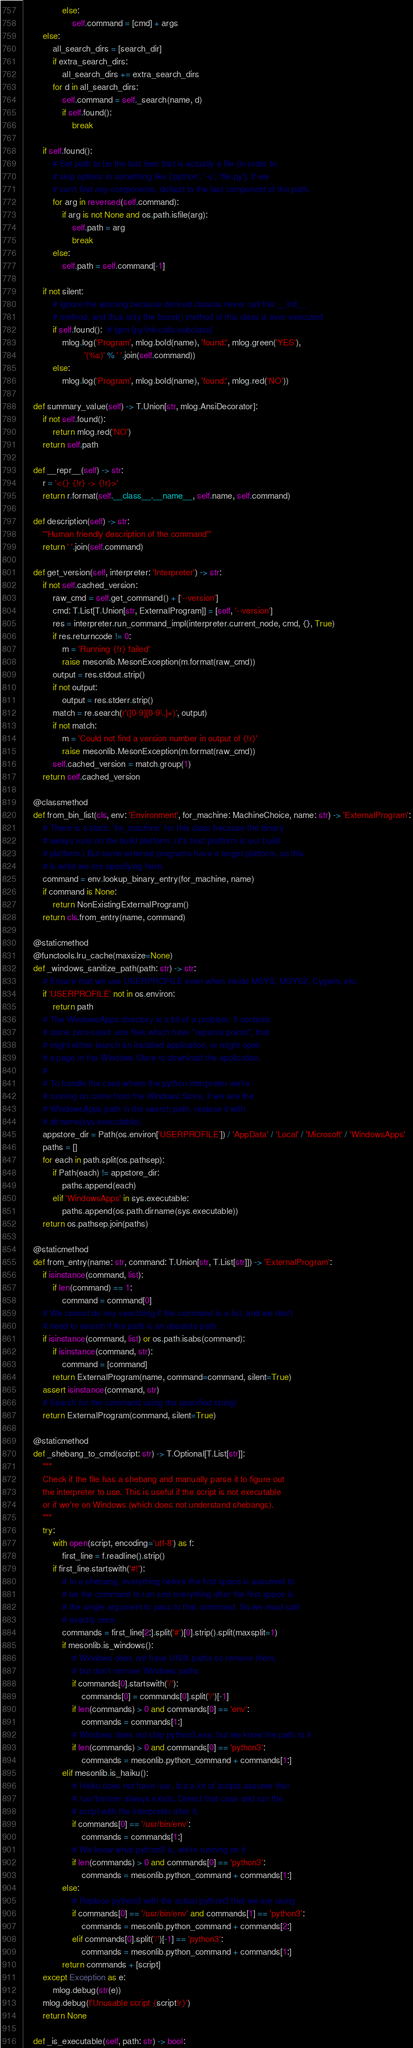<code> <loc_0><loc_0><loc_500><loc_500><_Python_>                else:
                    self.command = [cmd] + args
        else:
            all_search_dirs = [search_dir]
            if extra_search_dirs:
                all_search_dirs += extra_search_dirs
            for d in all_search_dirs:
                self.command = self._search(name, d)
                if self.found():
                    break

        if self.found():
            # Set path to be the last item that is actually a file (in order to
            # skip options in something like ['python', '-u', 'file.py']. If we
            # can't find any components, default to the last component of the path.
            for arg in reversed(self.command):
                if arg is not None and os.path.isfile(arg):
                    self.path = arg
                    break
            else:
                self.path = self.command[-1]

        if not silent:
            # ignore the warning because derived classes never call this __init__
            # method, and thus only the found() method of this class is ever executed
            if self.found():  # lgtm [py/init-calls-subclass]
                mlog.log('Program', mlog.bold(name), 'found:', mlog.green('YES'),
                         '(%s)' % ' '.join(self.command))
            else:
                mlog.log('Program', mlog.bold(name), 'found:', mlog.red('NO'))

    def summary_value(self) -> T.Union[str, mlog.AnsiDecorator]:
        if not self.found():
            return mlog.red('NO')
        return self.path

    def __repr__(self) -> str:
        r = '<{} {!r} -> {!r}>'
        return r.format(self.__class__.__name__, self.name, self.command)

    def description(self) -> str:
        '''Human friendly description of the command'''
        return ' '.join(self.command)

    def get_version(self, interpreter: 'Interpreter') -> str:
        if not self.cached_version:
            raw_cmd = self.get_command() + ['--version']
            cmd: T.List[T.Union[str, ExternalProgram]] = [self, '--version']
            res = interpreter.run_command_impl(interpreter.current_node, cmd, {}, True)
            if res.returncode != 0:
                m = 'Running {!r} failed'
                raise mesonlib.MesonException(m.format(raw_cmd))
            output = res.stdout.strip()
            if not output:
                output = res.stderr.strip()
            match = re.search(r'([0-9][0-9\.]+)', output)
            if not match:
                m = 'Could not find a version number in output of {!r}'
                raise mesonlib.MesonException(m.format(raw_cmd))
            self.cached_version = match.group(1)
        return self.cached_version

    @classmethod
    def from_bin_list(cls, env: 'Environment', for_machine: MachineChoice, name: str) -> 'ExternalProgram':
        # There is a static `for_machine` for this class because the binary
        # aways runs on the build platform. (It's host platform is our build
        # platform.) But some external programs have a target platform, so this
        # is what we are specifying here.
        command = env.lookup_binary_entry(for_machine, name)
        if command is None:
            return NonExistingExternalProgram()
        return cls.from_entry(name, command)

    @staticmethod
    @functools.lru_cache(maxsize=None)
    def _windows_sanitize_path(path: str) -> str:
        # Ensure that we use USERPROFILE even when inside MSYS, MSYS2, Cygwin, etc.
        if 'USERPROFILE' not in os.environ:
            return path
        # The WindowsApps directory is a bit of a problem. It contains
        # some zero-sized .exe files which have "reparse points", that
        # might either launch an installed application, or might open
        # a page in the Windows Store to download the application.
        #
        # To handle the case where the python interpreter we're
        # running on came from the Windows Store, if we see the
        # WindowsApps path in the search path, replace it with
        # dirname(sys.executable).
        appstore_dir = Path(os.environ['USERPROFILE']) / 'AppData' / 'Local' / 'Microsoft' / 'WindowsApps'
        paths = []
        for each in path.split(os.pathsep):
            if Path(each) != appstore_dir:
                paths.append(each)
            elif 'WindowsApps' in sys.executable:
                paths.append(os.path.dirname(sys.executable))
        return os.pathsep.join(paths)

    @staticmethod
    def from_entry(name: str, command: T.Union[str, T.List[str]]) -> 'ExternalProgram':
        if isinstance(command, list):
            if len(command) == 1:
                command = command[0]
        # We cannot do any searching if the command is a list, and we don't
        # need to search if the path is an absolute path.
        if isinstance(command, list) or os.path.isabs(command):
            if isinstance(command, str):
                command = [command]
            return ExternalProgram(name, command=command, silent=True)
        assert isinstance(command, str)
        # Search for the command using the specified string!
        return ExternalProgram(command, silent=True)

    @staticmethod
    def _shebang_to_cmd(script: str) -> T.Optional[T.List[str]]:
        """
        Check if the file has a shebang and manually parse it to figure out
        the interpreter to use. This is useful if the script is not executable
        or if we're on Windows (which does not understand shebangs).
        """
        try:
            with open(script, encoding='utf-8') as f:
                first_line = f.readline().strip()
            if first_line.startswith('#!'):
                # In a shebang, everything before the first space is assumed to
                # be the command to run and everything after the first space is
                # the single argument to pass to that command. So we must split
                # exactly once.
                commands = first_line[2:].split('#')[0].strip().split(maxsplit=1)
                if mesonlib.is_windows():
                    # Windows does not have UNIX paths so remove them,
                    # but don't remove Windows paths
                    if commands[0].startswith('/'):
                        commands[0] = commands[0].split('/')[-1]
                    if len(commands) > 0 and commands[0] == 'env':
                        commands = commands[1:]
                    # Windows does not ship python3.exe, but we know the path to it
                    if len(commands) > 0 and commands[0] == 'python3':
                        commands = mesonlib.python_command + commands[1:]
                elif mesonlib.is_haiku():
                    # Haiku does not have /usr, but a lot of scripts assume that
                    # /usr/bin/env always exists. Detect that case and run the
                    # script with the interpreter after it.
                    if commands[0] == '/usr/bin/env':
                        commands = commands[1:]
                    # We know what python3 is, we're running on it
                    if len(commands) > 0 and commands[0] == 'python3':
                        commands = mesonlib.python_command + commands[1:]
                else:
                    # Replace python3 with the actual python3 that we are using
                    if commands[0] == '/usr/bin/env' and commands[1] == 'python3':
                        commands = mesonlib.python_command + commands[2:]
                    elif commands[0].split('/')[-1] == 'python3':
                        commands = mesonlib.python_command + commands[1:]
                return commands + [script]
        except Exception as e:
            mlog.debug(str(e))
        mlog.debug(f'Unusable script {script!r}')
        return None

    def _is_executable(self, path: str) -> bool:</code> 